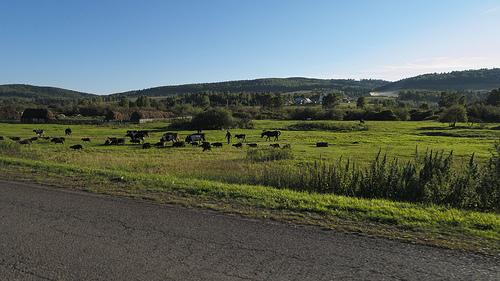What kind of road is in the picture and where is it located relative to the pasture? There is a paved road located next to the pasture. Name the image content that showcases flora in the image. Short green and brown grass, weeds at the edge of the pasture, a hillside full of green trees, a patch of green plants, and trees near a hillside. What do the white clouds over the blue sky evoke in the image? The white clouds in the blue sky evoke a sense of a peaceful and pleasant day with good weather. Describe any possible man-made structures present in the image. A livestock ranch next to the highway, a building next to the pasture, and buildings with straw roofs in the background are visible in the image. What is the primary activity of the person in the image? The person is walking in the pasture. Identify the primary landscape and weather conditions in the picture. A large grassy pasture with trees and bushes, and a crystal blue sky with white clouds. Mention the types of animals present in the image along with their count. The image includes 10 sheep, a horse, and two cows. What are the various types of grass and plant life visible in the image? Short green and brown grass, weeds at the edge of the pasture, a large grassy pasture, a patch of green plants, and a field of green grass. Describe the livestock that can be found in the picture. The livestock in the picture consists of brown cows, sheep, and a horse, all of which are grazing or walking in the pasture. 